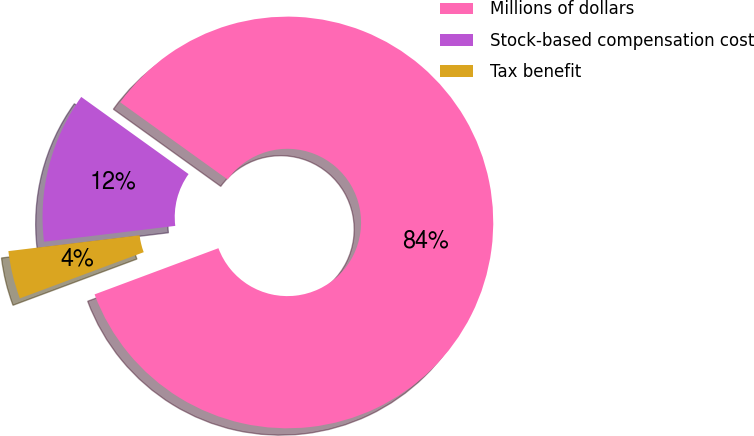<chart> <loc_0><loc_0><loc_500><loc_500><pie_chart><fcel>Millions of dollars<fcel>Stock-based compensation cost<fcel>Tax benefit<nl><fcel>84.39%<fcel>11.83%<fcel>3.77%<nl></chart> 